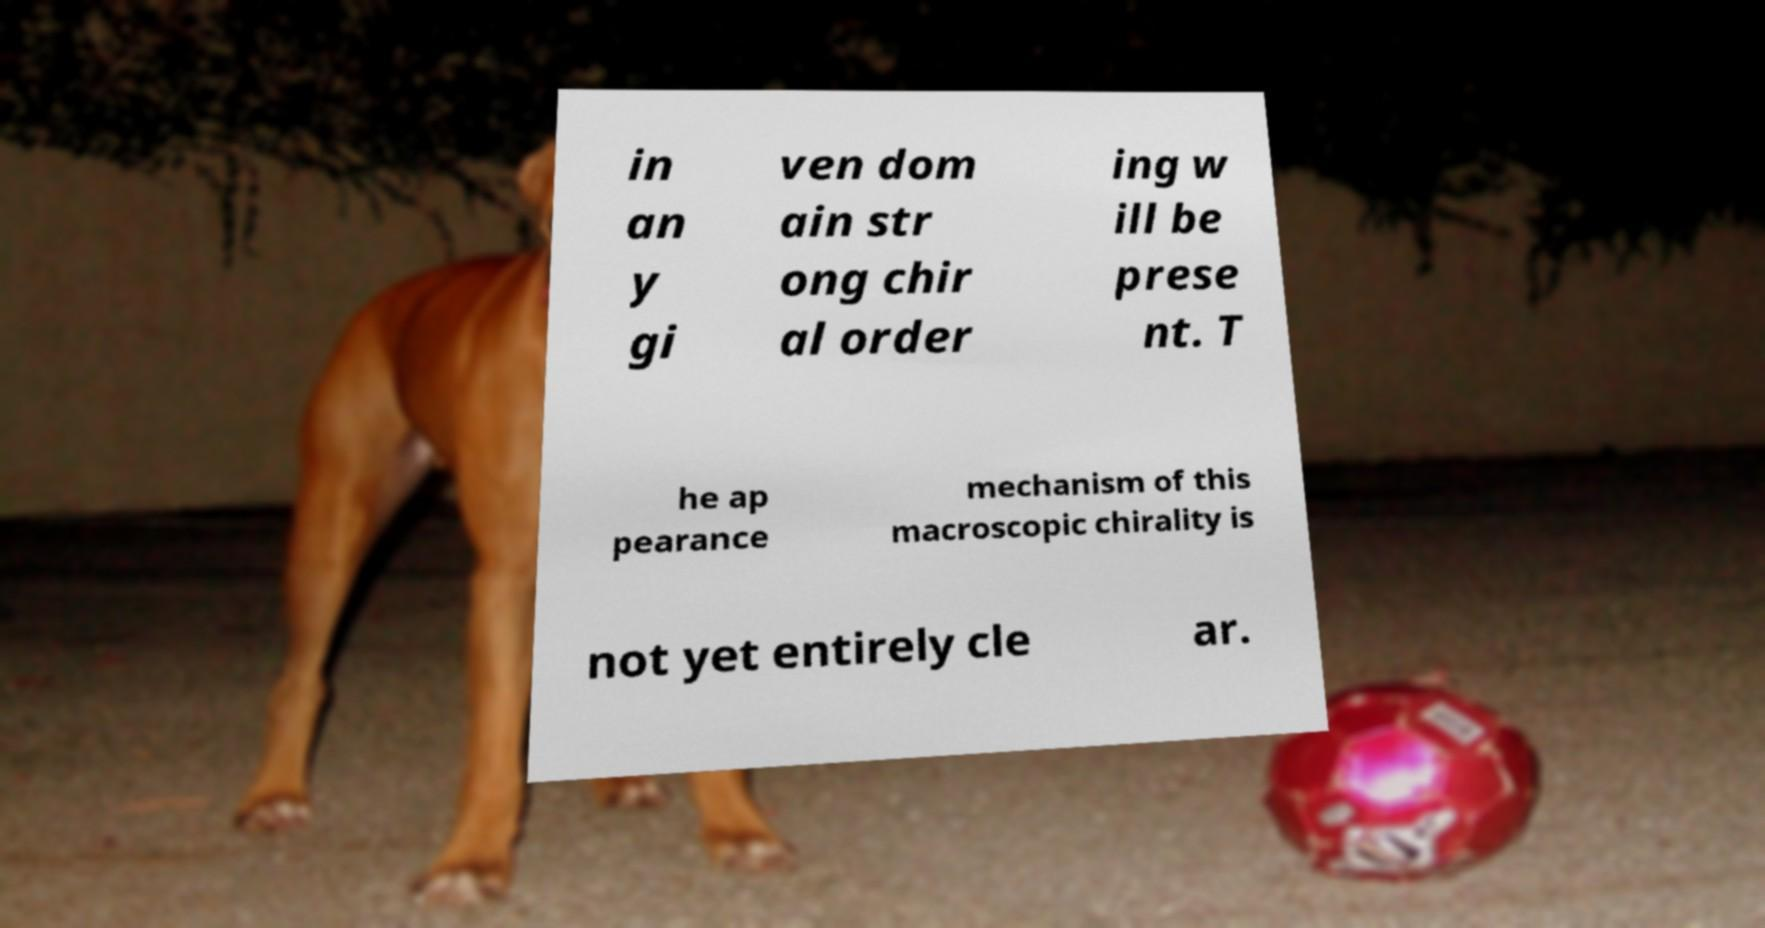There's text embedded in this image that I need extracted. Can you transcribe it verbatim? in an y gi ven dom ain str ong chir al order ing w ill be prese nt. T he ap pearance mechanism of this macroscopic chirality is not yet entirely cle ar. 